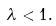Convert formula to latex. <formula><loc_0><loc_0><loc_500><loc_500>\lambda < 1 .</formula> 